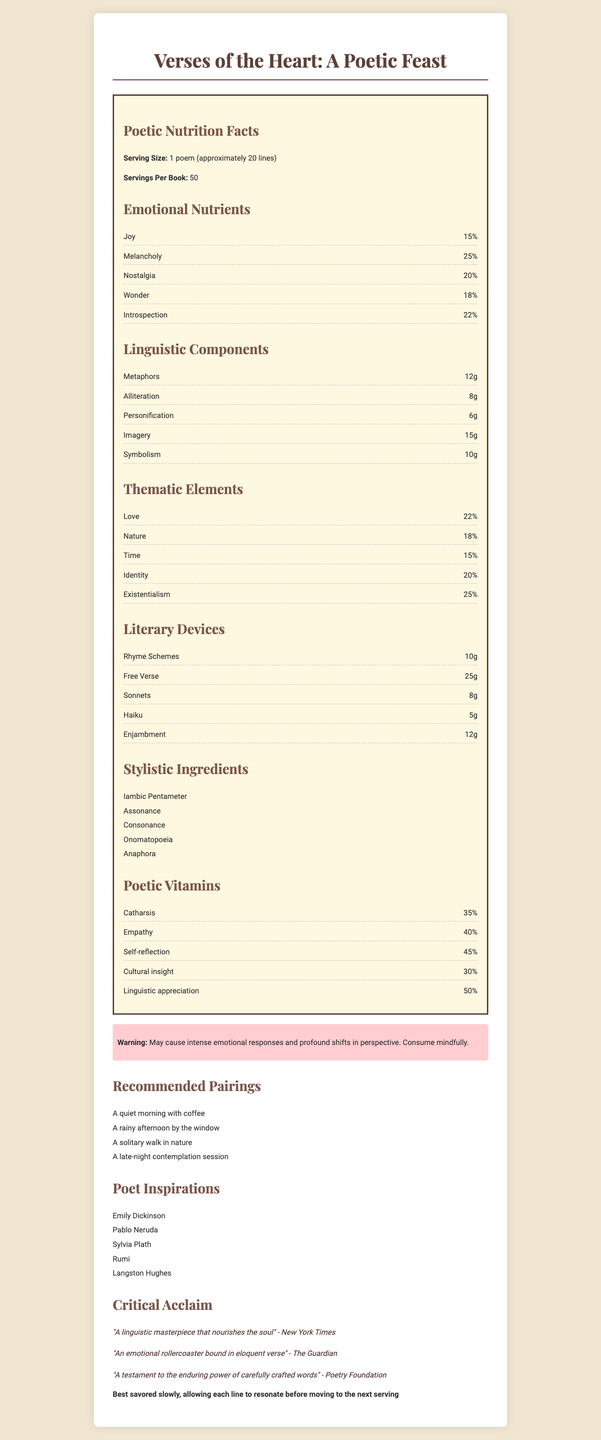what is the title of the book? The title is clearly stated at the top of the document under the Product_Name section.
Answer: Verses of the Heart: A Poetic Feast what is the serving size? The document specifies the serving size as 1 poem consisting of approximately 20 lines.
Answer: 1 poem (approximately 20 lines) how many servings are in the book? The document lists that there are 50 servings per book.
Answer: 50 what thematic element has the highest percentage? The thematic element with the highest percentage is Existentialism, at 25%.
Answer: Existentialism what emotional nutrient is the second most abundant? Melancholy is listed as 25%, making it the second most abundant emotional nutrient.
Answer: Melancholy which innovative lingual device is used the most in the book? Free Verse is the linguistic component with the highest quantity at 25g.
Answer: Free Verse is "Catharsis" a Poetic Vitamin listed in the document? Catharsis is listed among the Poetic Vitamins at 35%.
Answer: Yes what is one of the suggested pairings for enjoying the book? One of the recommended pairings is "A quiet morning with coffee".
Answer: A quiet morning with coffee who are some of the poets that inspired this collection? The Poetic Inspirations section lists these poets as influences for the collection.
Answer: Emily Dickinson, Pablo Neruda, Sylvia Plath, Rumi, Langston Hughes what is the critical acclaim from the New York Times? The New York Times calls it "A linguistic masterpiece that nourishes the soul".
Answer: A linguistic masterpiece that nourishes the soul which poetic vitamin has the highest percentage? A. Catharsis B. Empathy C. Self-reflection D. Cultural insight Self-reflection has the highest percentage among the Poetic Vitamins, at 45%.
Answer: C will reading the book affect your perspective? The warning indicates that the book "May cause intense emotional responses and profound shifts in perspective."
Answer: Yes summarize the entire document. The document provides an overview of the poetic collection, highlighting its emotional and linguistic elements, thematic concerns, literary devices, and additional insights such as critical acclaim and recommended reading pairings.
Answer: This document presents a poetic collection titled "Verses of the Heart: A Poetic Feast" with details on its emotional nutrients, linguistic richness, and poetic components. It includes thematic elements, literary devices used, and poetic vitamins provided by the work. Additionally, it offers recommended pairings for optimal enjoyment and shares critical acclaim from reputed sources. who is the author of the document? The document does not provide any information about the author.
Answer: Not enough information 